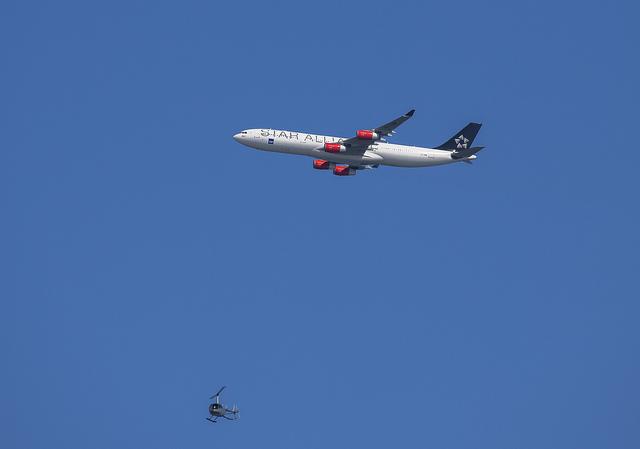Is the plane leaving or arriving?
Keep it brief. Leaving. Is the plane in motion?
Concise answer only. Yes. Which airline is this?
Concise answer only. Star alliance. Is this an action movie still?
Short answer required. No. Does it appear to be a nice day outside?
Short answer required. Yes. 